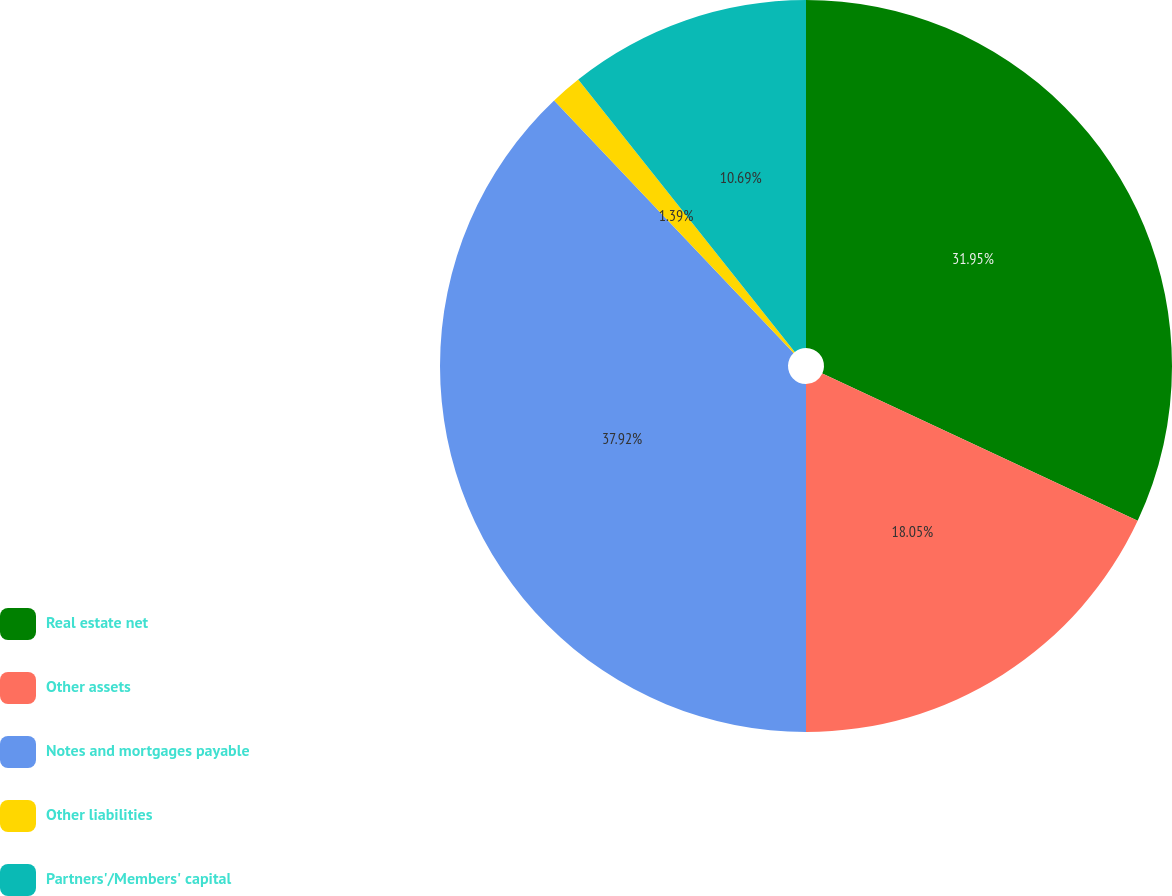Convert chart to OTSL. <chart><loc_0><loc_0><loc_500><loc_500><pie_chart><fcel>Real estate net<fcel>Other assets<fcel>Notes and mortgages payable<fcel>Other liabilities<fcel>Partners'/Members' capital<nl><fcel>31.95%<fcel>18.05%<fcel>37.92%<fcel>1.39%<fcel>10.69%<nl></chart> 